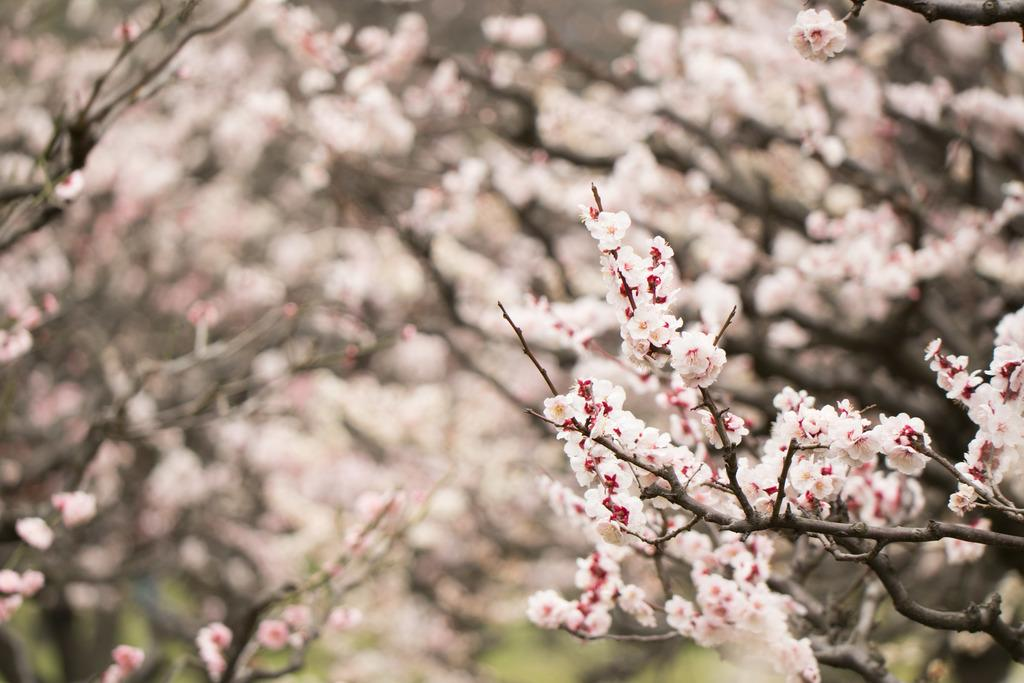What type of plants can be seen in the image? There are flowers in the image. What else can be seen in the image besides flowers? There are branches and trees in the image. How would you describe the background of the image? The background of the image is blurred. What are the names of the sisters in the image? There are no people, let alone sisters, present in the image. 